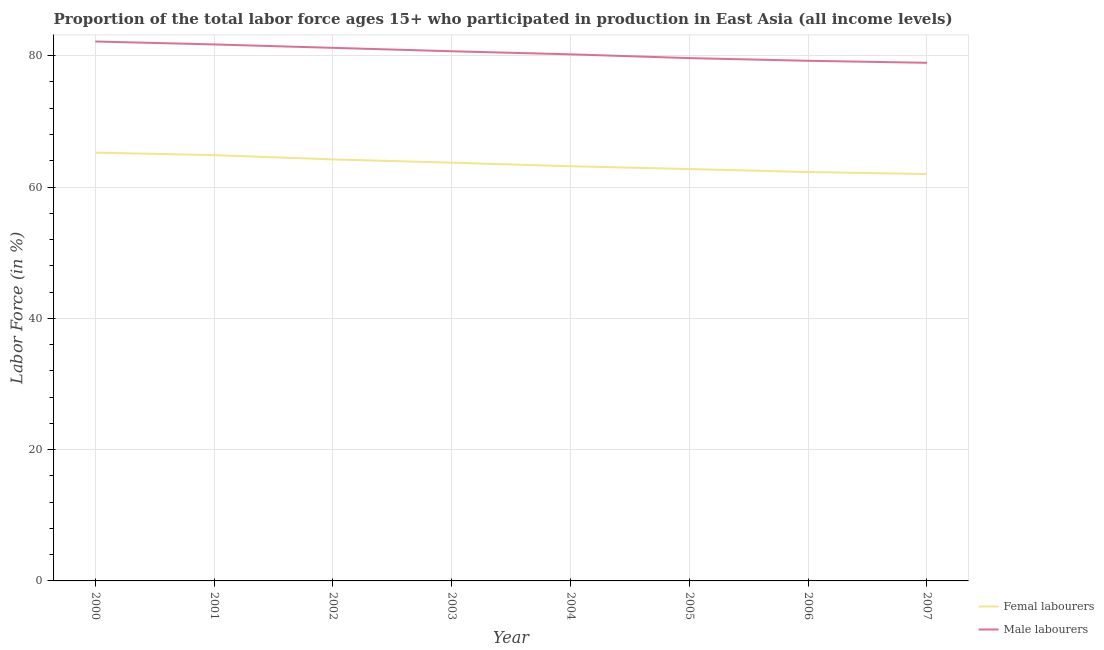Does the line corresponding to percentage of male labour force intersect with the line corresponding to percentage of female labor force?
Offer a very short reply. No. What is the percentage of female labor force in 2004?
Ensure brevity in your answer.  63.16. Across all years, what is the maximum percentage of female labor force?
Provide a succinct answer. 65.24. Across all years, what is the minimum percentage of male labour force?
Your answer should be compact. 78.92. What is the total percentage of male labour force in the graph?
Your response must be concise. 643.76. What is the difference between the percentage of female labor force in 2001 and that in 2006?
Give a very brief answer. 2.58. What is the difference between the percentage of female labor force in 2002 and the percentage of male labour force in 2000?
Give a very brief answer. -17.96. What is the average percentage of female labor force per year?
Give a very brief answer. 63.52. In the year 2005, what is the difference between the percentage of female labor force and percentage of male labour force?
Make the answer very short. -16.9. What is the ratio of the percentage of female labor force in 2003 to that in 2005?
Your answer should be compact. 1.02. Is the percentage of female labor force in 2003 less than that in 2004?
Make the answer very short. No. Is the difference between the percentage of female labor force in 2005 and 2007 greater than the difference between the percentage of male labour force in 2005 and 2007?
Your answer should be compact. Yes. What is the difference between the highest and the second highest percentage of female labor force?
Provide a short and direct response. 0.38. What is the difference between the highest and the lowest percentage of male labour force?
Make the answer very short. 3.24. In how many years, is the percentage of female labor force greater than the average percentage of female labor force taken over all years?
Make the answer very short. 4. Is the percentage of female labor force strictly less than the percentage of male labour force over the years?
Offer a very short reply. Yes. How many lines are there?
Ensure brevity in your answer.  2. Where does the legend appear in the graph?
Your answer should be very brief. Bottom right. What is the title of the graph?
Your answer should be very brief. Proportion of the total labor force ages 15+ who participated in production in East Asia (all income levels). What is the label or title of the X-axis?
Give a very brief answer. Year. What is the label or title of the Y-axis?
Provide a succinct answer. Labor Force (in %). What is the Labor Force (in %) of Femal labourers in 2000?
Give a very brief answer. 65.24. What is the Labor Force (in %) in Male labourers in 2000?
Offer a terse response. 82.16. What is the Labor Force (in %) of Femal labourers in 2001?
Your answer should be very brief. 64.86. What is the Labor Force (in %) of Male labourers in 2001?
Make the answer very short. 81.72. What is the Labor Force (in %) of Femal labourers in 2002?
Provide a succinct answer. 64.21. What is the Labor Force (in %) in Male labourers in 2002?
Give a very brief answer. 81.2. What is the Labor Force (in %) of Femal labourers in 2003?
Offer a very short reply. 63.71. What is the Labor Force (in %) in Male labourers in 2003?
Ensure brevity in your answer.  80.68. What is the Labor Force (in %) in Femal labourers in 2004?
Keep it short and to the point. 63.16. What is the Labor Force (in %) in Male labourers in 2004?
Make the answer very short. 80.21. What is the Labor Force (in %) of Femal labourers in 2005?
Ensure brevity in your answer.  62.74. What is the Labor Force (in %) in Male labourers in 2005?
Give a very brief answer. 79.63. What is the Labor Force (in %) of Femal labourers in 2006?
Your answer should be compact. 62.28. What is the Labor Force (in %) in Male labourers in 2006?
Your answer should be compact. 79.23. What is the Labor Force (in %) in Femal labourers in 2007?
Provide a short and direct response. 61.98. What is the Labor Force (in %) of Male labourers in 2007?
Offer a terse response. 78.92. Across all years, what is the maximum Labor Force (in %) in Femal labourers?
Offer a very short reply. 65.24. Across all years, what is the maximum Labor Force (in %) in Male labourers?
Give a very brief answer. 82.16. Across all years, what is the minimum Labor Force (in %) in Femal labourers?
Provide a short and direct response. 61.98. Across all years, what is the minimum Labor Force (in %) in Male labourers?
Provide a succinct answer. 78.92. What is the total Labor Force (in %) in Femal labourers in the graph?
Your answer should be compact. 508.17. What is the total Labor Force (in %) in Male labourers in the graph?
Provide a succinct answer. 643.76. What is the difference between the Labor Force (in %) of Femal labourers in 2000 and that in 2001?
Your answer should be compact. 0.38. What is the difference between the Labor Force (in %) in Male labourers in 2000 and that in 2001?
Make the answer very short. 0.44. What is the difference between the Labor Force (in %) of Femal labourers in 2000 and that in 2002?
Keep it short and to the point. 1.03. What is the difference between the Labor Force (in %) in Male labourers in 2000 and that in 2002?
Provide a short and direct response. 0.97. What is the difference between the Labor Force (in %) in Femal labourers in 2000 and that in 2003?
Provide a succinct answer. 1.53. What is the difference between the Labor Force (in %) in Male labourers in 2000 and that in 2003?
Give a very brief answer. 1.49. What is the difference between the Labor Force (in %) in Femal labourers in 2000 and that in 2004?
Your answer should be compact. 2.08. What is the difference between the Labor Force (in %) in Male labourers in 2000 and that in 2004?
Your answer should be very brief. 1.95. What is the difference between the Labor Force (in %) of Femal labourers in 2000 and that in 2005?
Provide a short and direct response. 2.5. What is the difference between the Labor Force (in %) in Male labourers in 2000 and that in 2005?
Provide a succinct answer. 2.53. What is the difference between the Labor Force (in %) in Femal labourers in 2000 and that in 2006?
Ensure brevity in your answer.  2.96. What is the difference between the Labor Force (in %) of Male labourers in 2000 and that in 2006?
Provide a short and direct response. 2.94. What is the difference between the Labor Force (in %) in Femal labourers in 2000 and that in 2007?
Provide a short and direct response. 3.26. What is the difference between the Labor Force (in %) of Male labourers in 2000 and that in 2007?
Give a very brief answer. 3.24. What is the difference between the Labor Force (in %) of Femal labourers in 2001 and that in 2002?
Keep it short and to the point. 0.65. What is the difference between the Labor Force (in %) of Male labourers in 2001 and that in 2002?
Give a very brief answer. 0.52. What is the difference between the Labor Force (in %) in Femal labourers in 2001 and that in 2003?
Provide a succinct answer. 1.15. What is the difference between the Labor Force (in %) of Male labourers in 2001 and that in 2003?
Provide a short and direct response. 1.04. What is the difference between the Labor Force (in %) of Femal labourers in 2001 and that in 2004?
Keep it short and to the point. 1.7. What is the difference between the Labor Force (in %) of Male labourers in 2001 and that in 2004?
Provide a succinct answer. 1.51. What is the difference between the Labor Force (in %) of Femal labourers in 2001 and that in 2005?
Provide a short and direct response. 2.12. What is the difference between the Labor Force (in %) in Male labourers in 2001 and that in 2005?
Ensure brevity in your answer.  2.09. What is the difference between the Labor Force (in %) of Femal labourers in 2001 and that in 2006?
Provide a short and direct response. 2.58. What is the difference between the Labor Force (in %) of Male labourers in 2001 and that in 2006?
Provide a short and direct response. 2.49. What is the difference between the Labor Force (in %) in Femal labourers in 2001 and that in 2007?
Provide a succinct answer. 2.88. What is the difference between the Labor Force (in %) of Male labourers in 2001 and that in 2007?
Your response must be concise. 2.8. What is the difference between the Labor Force (in %) of Femal labourers in 2002 and that in 2003?
Provide a succinct answer. 0.5. What is the difference between the Labor Force (in %) of Male labourers in 2002 and that in 2003?
Your response must be concise. 0.52. What is the difference between the Labor Force (in %) in Femal labourers in 2002 and that in 2004?
Provide a succinct answer. 1.04. What is the difference between the Labor Force (in %) of Male labourers in 2002 and that in 2004?
Your response must be concise. 0.99. What is the difference between the Labor Force (in %) of Femal labourers in 2002 and that in 2005?
Offer a terse response. 1.47. What is the difference between the Labor Force (in %) of Male labourers in 2002 and that in 2005?
Your response must be concise. 1.56. What is the difference between the Labor Force (in %) in Femal labourers in 2002 and that in 2006?
Offer a terse response. 1.93. What is the difference between the Labor Force (in %) of Male labourers in 2002 and that in 2006?
Offer a terse response. 1.97. What is the difference between the Labor Force (in %) in Femal labourers in 2002 and that in 2007?
Make the answer very short. 2.23. What is the difference between the Labor Force (in %) of Male labourers in 2002 and that in 2007?
Your response must be concise. 2.28. What is the difference between the Labor Force (in %) in Femal labourers in 2003 and that in 2004?
Your answer should be compact. 0.54. What is the difference between the Labor Force (in %) in Male labourers in 2003 and that in 2004?
Ensure brevity in your answer.  0.47. What is the difference between the Labor Force (in %) in Male labourers in 2003 and that in 2005?
Your response must be concise. 1.04. What is the difference between the Labor Force (in %) of Femal labourers in 2003 and that in 2006?
Make the answer very short. 1.43. What is the difference between the Labor Force (in %) in Male labourers in 2003 and that in 2006?
Your response must be concise. 1.45. What is the difference between the Labor Force (in %) in Femal labourers in 2003 and that in 2007?
Give a very brief answer. 1.73. What is the difference between the Labor Force (in %) of Male labourers in 2003 and that in 2007?
Give a very brief answer. 1.76. What is the difference between the Labor Force (in %) of Femal labourers in 2004 and that in 2005?
Offer a very short reply. 0.42. What is the difference between the Labor Force (in %) of Male labourers in 2004 and that in 2005?
Your answer should be very brief. 0.58. What is the difference between the Labor Force (in %) of Femal labourers in 2004 and that in 2006?
Make the answer very short. 0.88. What is the difference between the Labor Force (in %) in Male labourers in 2004 and that in 2006?
Provide a succinct answer. 0.98. What is the difference between the Labor Force (in %) in Femal labourers in 2004 and that in 2007?
Ensure brevity in your answer.  1.18. What is the difference between the Labor Force (in %) in Male labourers in 2004 and that in 2007?
Your response must be concise. 1.29. What is the difference between the Labor Force (in %) in Femal labourers in 2005 and that in 2006?
Offer a terse response. 0.46. What is the difference between the Labor Force (in %) in Male labourers in 2005 and that in 2006?
Provide a short and direct response. 0.41. What is the difference between the Labor Force (in %) of Femal labourers in 2005 and that in 2007?
Your answer should be very brief. 0.76. What is the difference between the Labor Force (in %) of Male labourers in 2005 and that in 2007?
Keep it short and to the point. 0.71. What is the difference between the Labor Force (in %) of Femal labourers in 2006 and that in 2007?
Give a very brief answer. 0.3. What is the difference between the Labor Force (in %) in Male labourers in 2006 and that in 2007?
Provide a succinct answer. 0.31. What is the difference between the Labor Force (in %) of Femal labourers in 2000 and the Labor Force (in %) of Male labourers in 2001?
Make the answer very short. -16.48. What is the difference between the Labor Force (in %) of Femal labourers in 2000 and the Labor Force (in %) of Male labourers in 2002?
Provide a short and direct response. -15.96. What is the difference between the Labor Force (in %) of Femal labourers in 2000 and the Labor Force (in %) of Male labourers in 2003?
Your answer should be very brief. -15.44. What is the difference between the Labor Force (in %) of Femal labourers in 2000 and the Labor Force (in %) of Male labourers in 2004?
Ensure brevity in your answer.  -14.97. What is the difference between the Labor Force (in %) of Femal labourers in 2000 and the Labor Force (in %) of Male labourers in 2005?
Provide a succinct answer. -14.4. What is the difference between the Labor Force (in %) of Femal labourers in 2000 and the Labor Force (in %) of Male labourers in 2006?
Ensure brevity in your answer.  -13.99. What is the difference between the Labor Force (in %) in Femal labourers in 2000 and the Labor Force (in %) in Male labourers in 2007?
Your answer should be very brief. -13.68. What is the difference between the Labor Force (in %) of Femal labourers in 2001 and the Labor Force (in %) of Male labourers in 2002?
Ensure brevity in your answer.  -16.34. What is the difference between the Labor Force (in %) in Femal labourers in 2001 and the Labor Force (in %) in Male labourers in 2003?
Offer a terse response. -15.82. What is the difference between the Labor Force (in %) in Femal labourers in 2001 and the Labor Force (in %) in Male labourers in 2004?
Ensure brevity in your answer.  -15.35. What is the difference between the Labor Force (in %) of Femal labourers in 2001 and the Labor Force (in %) of Male labourers in 2005?
Your answer should be compact. -14.78. What is the difference between the Labor Force (in %) in Femal labourers in 2001 and the Labor Force (in %) in Male labourers in 2006?
Offer a very short reply. -14.37. What is the difference between the Labor Force (in %) of Femal labourers in 2001 and the Labor Force (in %) of Male labourers in 2007?
Ensure brevity in your answer.  -14.06. What is the difference between the Labor Force (in %) in Femal labourers in 2002 and the Labor Force (in %) in Male labourers in 2003?
Your answer should be compact. -16.47. What is the difference between the Labor Force (in %) of Femal labourers in 2002 and the Labor Force (in %) of Male labourers in 2004?
Provide a succinct answer. -16.01. What is the difference between the Labor Force (in %) of Femal labourers in 2002 and the Labor Force (in %) of Male labourers in 2005?
Provide a short and direct response. -15.43. What is the difference between the Labor Force (in %) in Femal labourers in 2002 and the Labor Force (in %) in Male labourers in 2006?
Make the answer very short. -15.02. What is the difference between the Labor Force (in %) of Femal labourers in 2002 and the Labor Force (in %) of Male labourers in 2007?
Your answer should be compact. -14.72. What is the difference between the Labor Force (in %) in Femal labourers in 2003 and the Labor Force (in %) in Male labourers in 2004?
Your answer should be compact. -16.51. What is the difference between the Labor Force (in %) of Femal labourers in 2003 and the Labor Force (in %) of Male labourers in 2005?
Provide a short and direct response. -15.93. What is the difference between the Labor Force (in %) of Femal labourers in 2003 and the Labor Force (in %) of Male labourers in 2006?
Keep it short and to the point. -15.52. What is the difference between the Labor Force (in %) in Femal labourers in 2003 and the Labor Force (in %) in Male labourers in 2007?
Keep it short and to the point. -15.22. What is the difference between the Labor Force (in %) of Femal labourers in 2004 and the Labor Force (in %) of Male labourers in 2005?
Give a very brief answer. -16.47. What is the difference between the Labor Force (in %) of Femal labourers in 2004 and the Labor Force (in %) of Male labourers in 2006?
Offer a very short reply. -16.07. What is the difference between the Labor Force (in %) of Femal labourers in 2004 and the Labor Force (in %) of Male labourers in 2007?
Make the answer very short. -15.76. What is the difference between the Labor Force (in %) in Femal labourers in 2005 and the Labor Force (in %) in Male labourers in 2006?
Your response must be concise. -16.49. What is the difference between the Labor Force (in %) in Femal labourers in 2005 and the Labor Force (in %) in Male labourers in 2007?
Ensure brevity in your answer.  -16.18. What is the difference between the Labor Force (in %) in Femal labourers in 2006 and the Labor Force (in %) in Male labourers in 2007?
Give a very brief answer. -16.64. What is the average Labor Force (in %) of Femal labourers per year?
Give a very brief answer. 63.52. What is the average Labor Force (in %) in Male labourers per year?
Make the answer very short. 80.47. In the year 2000, what is the difference between the Labor Force (in %) in Femal labourers and Labor Force (in %) in Male labourers?
Your answer should be very brief. -16.93. In the year 2001, what is the difference between the Labor Force (in %) of Femal labourers and Labor Force (in %) of Male labourers?
Your response must be concise. -16.86. In the year 2002, what is the difference between the Labor Force (in %) in Femal labourers and Labor Force (in %) in Male labourers?
Your answer should be very brief. -16.99. In the year 2003, what is the difference between the Labor Force (in %) in Femal labourers and Labor Force (in %) in Male labourers?
Keep it short and to the point. -16.97. In the year 2004, what is the difference between the Labor Force (in %) in Femal labourers and Labor Force (in %) in Male labourers?
Provide a short and direct response. -17.05. In the year 2005, what is the difference between the Labor Force (in %) in Femal labourers and Labor Force (in %) in Male labourers?
Your response must be concise. -16.9. In the year 2006, what is the difference between the Labor Force (in %) in Femal labourers and Labor Force (in %) in Male labourers?
Offer a terse response. -16.95. In the year 2007, what is the difference between the Labor Force (in %) in Femal labourers and Labor Force (in %) in Male labourers?
Your answer should be compact. -16.94. What is the ratio of the Labor Force (in %) in Femal labourers in 2000 to that in 2001?
Keep it short and to the point. 1.01. What is the ratio of the Labor Force (in %) in Male labourers in 2000 to that in 2001?
Keep it short and to the point. 1.01. What is the ratio of the Labor Force (in %) of Femal labourers in 2000 to that in 2002?
Offer a terse response. 1.02. What is the ratio of the Labor Force (in %) in Male labourers in 2000 to that in 2002?
Offer a very short reply. 1.01. What is the ratio of the Labor Force (in %) in Femal labourers in 2000 to that in 2003?
Give a very brief answer. 1.02. What is the ratio of the Labor Force (in %) of Male labourers in 2000 to that in 2003?
Give a very brief answer. 1.02. What is the ratio of the Labor Force (in %) in Femal labourers in 2000 to that in 2004?
Your answer should be compact. 1.03. What is the ratio of the Labor Force (in %) in Male labourers in 2000 to that in 2004?
Your answer should be very brief. 1.02. What is the ratio of the Labor Force (in %) of Femal labourers in 2000 to that in 2005?
Offer a very short reply. 1.04. What is the ratio of the Labor Force (in %) of Male labourers in 2000 to that in 2005?
Offer a terse response. 1.03. What is the ratio of the Labor Force (in %) in Femal labourers in 2000 to that in 2006?
Provide a short and direct response. 1.05. What is the ratio of the Labor Force (in %) of Male labourers in 2000 to that in 2006?
Offer a terse response. 1.04. What is the ratio of the Labor Force (in %) of Femal labourers in 2000 to that in 2007?
Your answer should be very brief. 1.05. What is the ratio of the Labor Force (in %) of Male labourers in 2000 to that in 2007?
Your response must be concise. 1.04. What is the ratio of the Labor Force (in %) of Male labourers in 2001 to that in 2002?
Keep it short and to the point. 1.01. What is the ratio of the Labor Force (in %) of Femal labourers in 2001 to that in 2003?
Your answer should be very brief. 1.02. What is the ratio of the Labor Force (in %) of Male labourers in 2001 to that in 2003?
Your response must be concise. 1.01. What is the ratio of the Labor Force (in %) in Femal labourers in 2001 to that in 2004?
Ensure brevity in your answer.  1.03. What is the ratio of the Labor Force (in %) in Male labourers in 2001 to that in 2004?
Offer a very short reply. 1.02. What is the ratio of the Labor Force (in %) of Femal labourers in 2001 to that in 2005?
Ensure brevity in your answer.  1.03. What is the ratio of the Labor Force (in %) in Male labourers in 2001 to that in 2005?
Make the answer very short. 1.03. What is the ratio of the Labor Force (in %) of Femal labourers in 2001 to that in 2006?
Keep it short and to the point. 1.04. What is the ratio of the Labor Force (in %) of Male labourers in 2001 to that in 2006?
Ensure brevity in your answer.  1.03. What is the ratio of the Labor Force (in %) in Femal labourers in 2001 to that in 2007?
Offer a very short reply. 1.05. What is the ratio of the Labor Force (in %) of Male labourers in 2001 to that in 2007?
Ensure brevity in your answer.  1.04. What is the ratio of the Labor Force (in %) in Femal labourers in 2002 to that in 2003?
Provide a short and direct response. 1.01. What is the ratio of the Labor Force (in %) of Male labourers in 2002 to that in 2003?
Provide a succinct answer. 1.01. What is the ratio of the Labor Force (in %) of Femal labourers in 2002 to that in 2004?
Keep it short and to the point. 1.02. What is the ratio of the Labor Force (in %) in Male labourers in 2002 to that in 2004?
Keep it short and to the point. 1.01. What is the ratio of the Labor Force (in %) of Femal labourers in 2002 to that in 2005?
Provide a short and direct response. 1.02. What is the ratio of the Labor Force (in %) in Male labourers in 2002 to that in 2005?
Make the answer very short. 1.02. What is the ratio of the Labor Force (in %) of Femal labourers in 2002 to that in 2006?
Your answer should be very brief. 1.03. What is the ratio of the Labor Force (in %) of Male labourers in 2002 to that in 2006?
Ensure brevity in your answer.  1.02. What is the ratio of the Labor Force (in %) of Femal labourers in 2002 to that in 2007?
Offer a terse response. 1.04. What is the ratio of the Labor Force (in %) in Male labourers in 2002 to that in 2007?
Give a very brief answer. 1.03. What is the ratio of the Labor Force (in %) in Femal labourers in 2003 to that in 2004?
Your response must be concise. 1.01. What is the ratio of the Labor Force (in %) in Femal labourers in 2003 to that in 2005?
Give a very brief answer. 1.02. What is the ratio of the Labor Force (in %) in Male labourers in 2003 to that in 2005?
Provide a short and direct response. 1.01. What is the ratio of the Labor Force (in %) in Femal labourers in 2003 to that in 2006?
Give a very brief answer. 1.02. What is the ratio of the Labor Force (in %) of Male labourers in 2003 to that in 2006?
Give a very brief answer. 1.02. What is the ratio of the Labor Force (in %) of Femal labourers in 2003 to that in 2007?
Your response must be concise. 1.03. What is the ratio of the Labor Force (in %) of Male labourers in 2003 to that in 2007?
Provide a succinct answer. 1.02. What is the ratio of the Labor Force (in %) of Femal labourers in 2004 to that in 2005?
Provide a succinct answer. 1.01. What is the ratio of the Labor Force (in %) in Male labourers in 2004 to that in 2005?
Make the answer very short. 1.01. What is the ratio of the Labor Force (in %) in Femal labourers in 2004 to that in 2006?
Your answer should be very brief. 1.01. What is the ratio of the Labor Force (in %) in Male labourers in 2004 to that in 2006?
Give a very brief answer. 1.01. What is the ratio of the Labor Force (in %) of Femal labourers in 2004 to that in 2007?
Give a very brief answer. 1.02. What is the ratio of the Labor Force (in %) in Male labourers in 2004 to that in 2007?
Give a very brief answer. 1.02. What is the ratio of the Labor Force (in %) in Femal labourers in 2005 to that in 2006?
Your answer should be very brief. 1.01. What is the ratio of the Labor Force (in %) of Male labourers in 2005 to that in 2006?
Offer a terse response. 1.01. What is the ratio of the Labor Force (in %) of Femal labourers in 2005 to that in 2007?
Keep it short and to the point. 1.01. What is the difference between the highest and the second highest Labor Force (in %) in Femal labourers?
Make the answer very short. 0.38. What is the difference between the highest and the second highest Labor Force (in %) of Male labourers?
Offer a terse response. 0.44. What is the difference between the highest and the lowest Labor Force (in %) in Femal labourers?
Your answer should be compact. 3.26. What is the difference between the highest and the lowest Labor Force (in %) in Male labourers?
Provide a succinct answer. 3.24. 